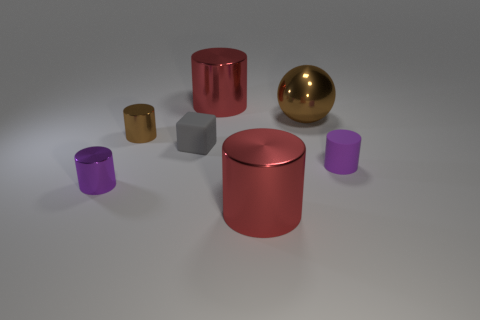Subtract all shiny cylinders. How many cylinders are left? 1 Add 1 matte objects. How many objects exist? 8 Subtract all cubes. How many objects are left? 6 Subtract all brown cylinders. How many cylinders are left? 4 Subtract 0 cyan cubes. How many objects are left? 7 Subtract 1 cubes. How many cubes are left? 0 Subtract all purple spheres. Subtract all yellow cylinders. How many spheres are left? 1 Subtract all cyan balls. How many red cylinders are left? 2 Subtract all big yellow metal cylinders. Subtract all brown cylinders. How many objects are left? 6 Add 2 brown cylinders. How many brown cylinders are left? 3 